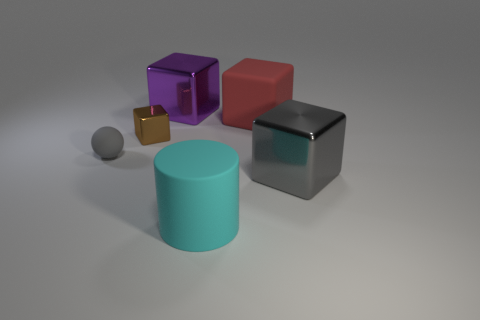What material is the gray thing that is to the left of the metallic thing behind the small brown metal thing made of?
Ensure brevity in your answer.  Rubber. Are any tiny cyan metal things visible?
Your answer should be compact. No. There is a rubber thing that is in front of the big metallic cube in front of the tiny shiny cube; what size is it?
Ensure brevity in your answer.  Large. Are there more blocks that are in front of the red block than large purple things that are to the left of the purple metal block?
Offer a very short reply. Yes. What number of cylinders are either cyan matte things or tiny brown objects?
Ensure brevity in your answer.  1. Do the gray thing on the right side of the large cyan object and the red thing have the same shape?
Provide a succinct answer. Yes. What is the color of the small matte thing?
Make the answer very short. Gray. There is a tiny object that is the same shape as the big red rubber thing; what is its color?
Give a very brief answer. Brown. What number of small gray objects are the same shape as the big purple metallic thing?
Keep it short and to the point. 0. How many objects are small cyan blocks or shiny blocks that are in front of the brown thing?
Provide a succinct answer. 1. 